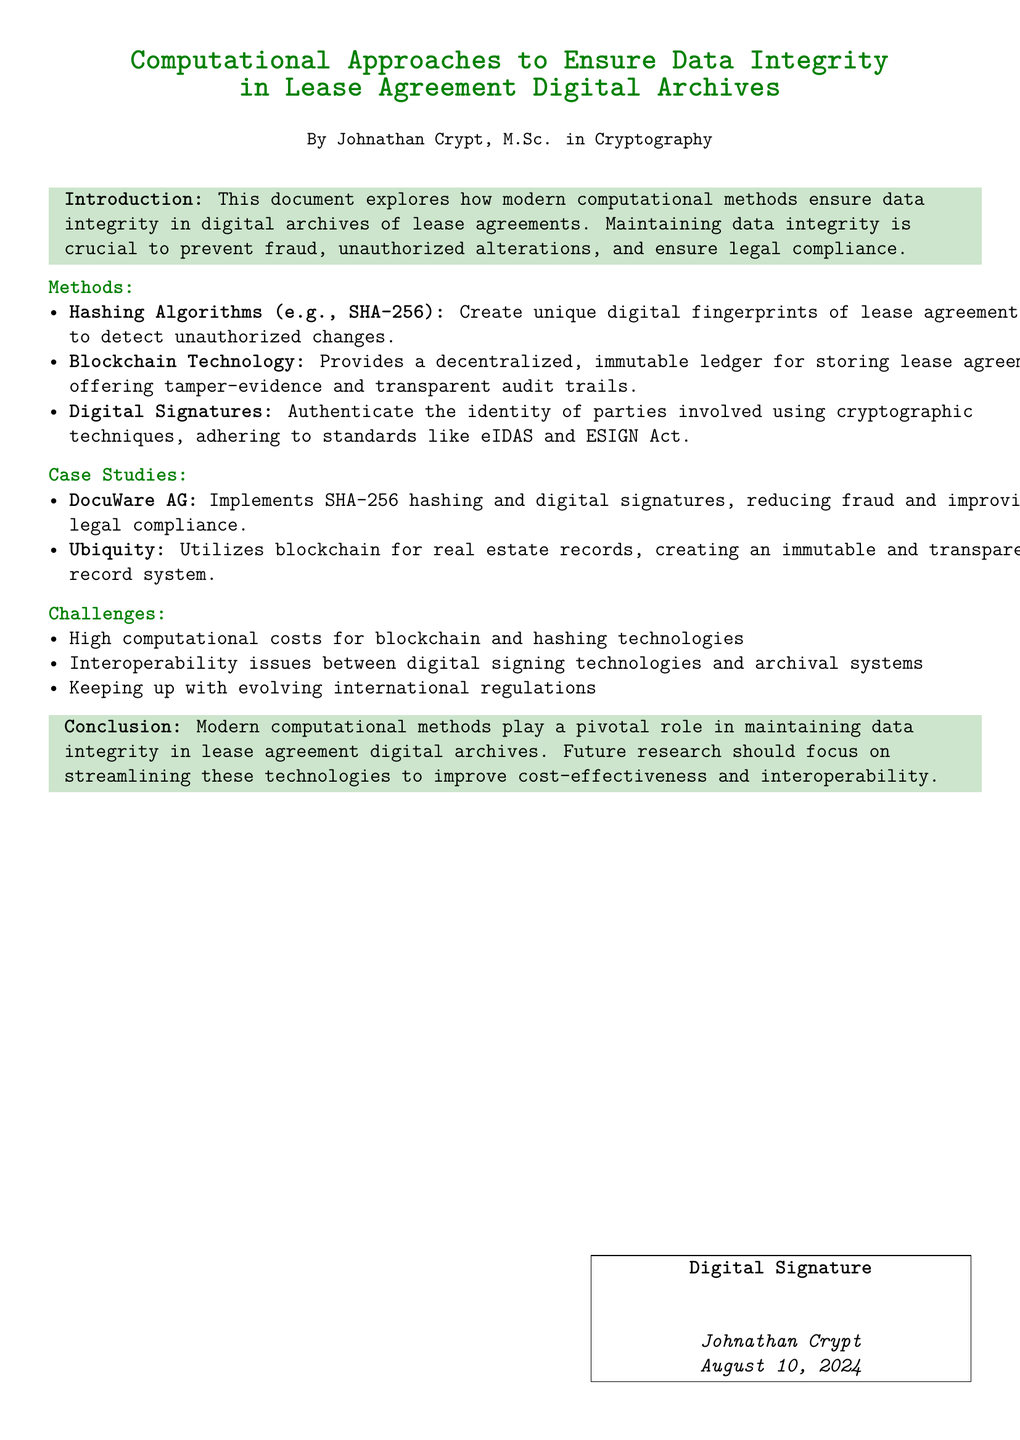What is the title of the document? The title is presented prominently at the top of the document.
Answer: Computational Approaches to Ensure Data Integrity in Lease Agreement Digital Archives Who is the author of the document? The author information appears at the bottom of the title section.
Answer: Johnathan Crypt What hashing algorithm is mentioned in the document? The document lists specific methods used for data integrity, including a hashing algorithm.
Answer: SHA-256 Which company implements SHA-256 hashing according to the case studies? The case studies highlight specific companies and their implementations regarding data integrity.
Answer: DocuWare AG What is one of the challenges mentioned in the document? The challenges section outlines issues faced in implementing the described methods.
Answer: High computational costs What technology provides a decentralized ledger for lease agreements? The methods section details various technologies used for maintaining data integrity.
Answer: Blockchain Technology What should future research focus on according to the conclusion? The conclusion outlines considerations for advancing the methodologies discussed in the document.
Answer: Streamlining technologies What date is listed in the document? The date is found in the signature section at the bottom of the document.
Answer: Today’s date What act is mentioned as a standard for digital signatures? The methods section discusses the legal standards applicable to digital signatures.
Answer: ESIGN Act 